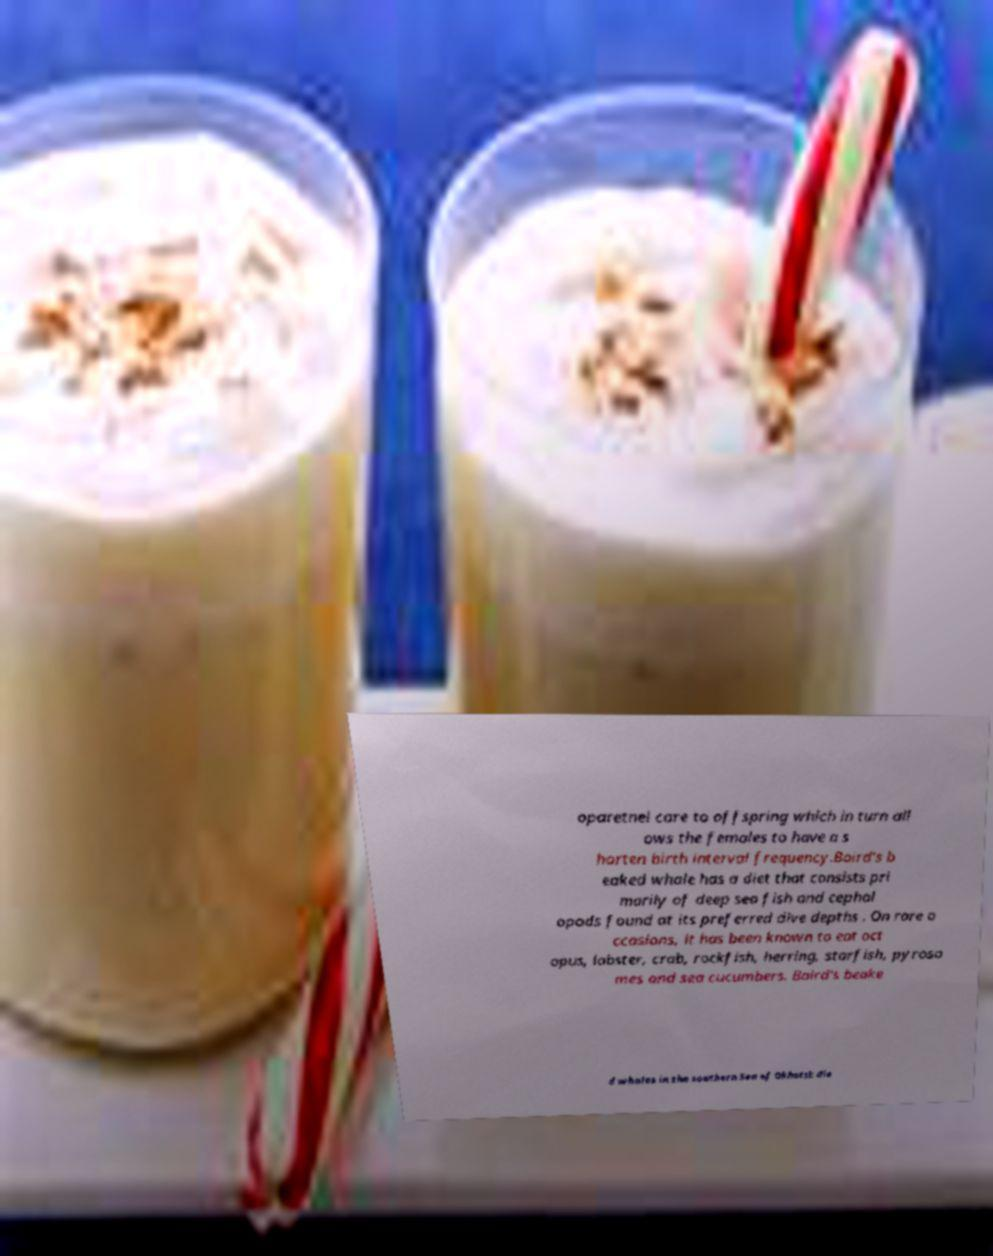Please identify and transcribe the text found in this image. oparetnel care to offspring which in turn all ows the females to have a s horten birth interval frequency.Baird's b eaked whale has a diet that consists pri marily of deep sea fish and cephal opods found at its preferred dive depths . On rare o ccasions, it has been known to eat oct opus, lobster, crab, rockfish, herring, starfish, pyroso mes and sea cucumbers. Baird's beake d whales in the southern Sea of Okhotsk die 